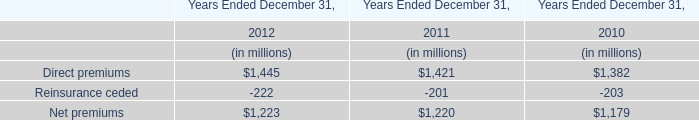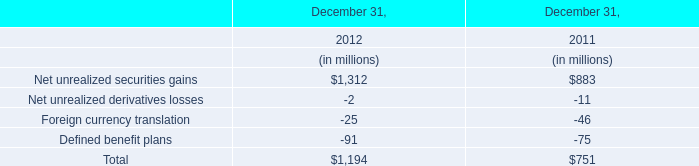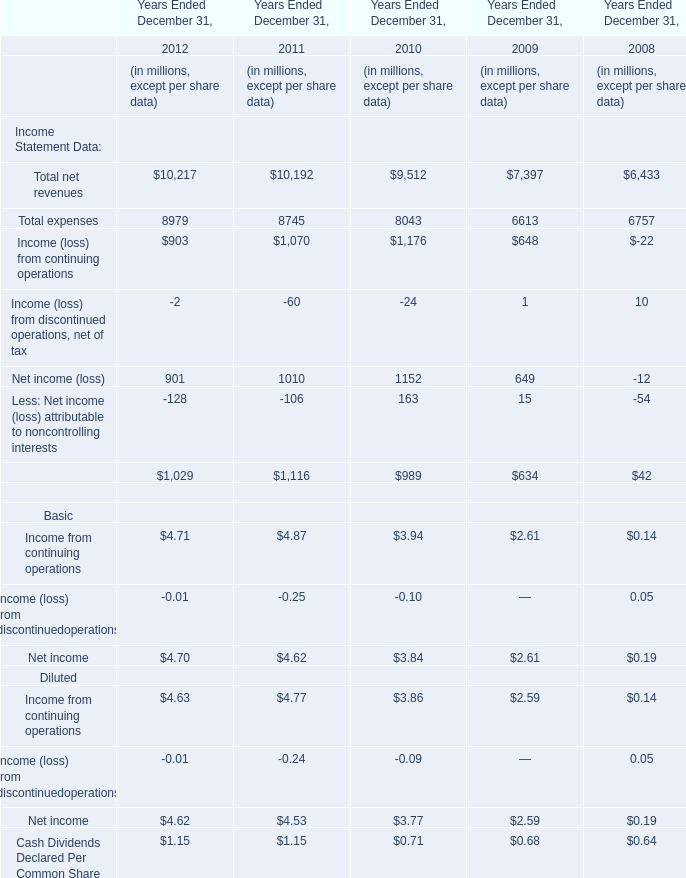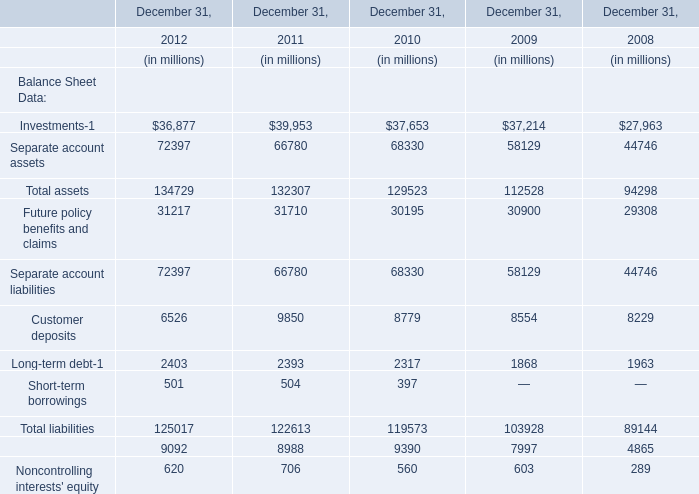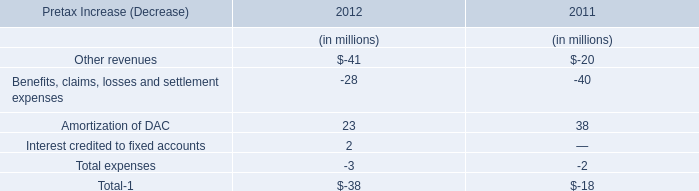In the year with largest amount of Total net revenues, what's the sum of Total expenses? (in million) 
Answer: 8979. 